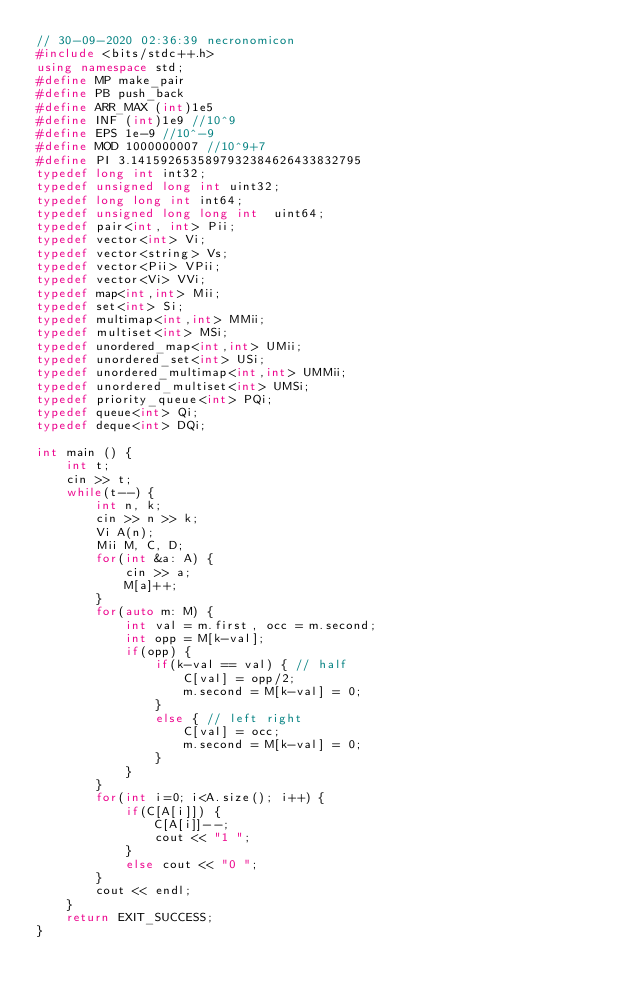<code> <loc_0><loc_0><loc_500><loc_500><_C++_>// 30-09-2020 02:36:39 necronomicon
#include <bits/stdc++.h>
using namespace std;
#define MP make_pair
#define PB push_back
#define ARR_MAX (int)1e5
#define INF (int)1e9 //10^9
#define EPS 1e-9 //10^-9
#define MOD 1000000007 //10^9+7
#define PI 3.1415926535897932384626433832795
typedef long int int32;
typedef unsigned long int uint32;
typedef long long int int64;
typedef unsigned long long int  uint64;
typedef pair<int, int> Pii;
typedef vector<int> Vi;
typedef vector<string> Vs;
typedef vector<Pii> VPii;
typedef vector<Vi> VVi;
typedef map<int,int> Mii;
typedef set<int> Si;
typedef multimap<int,int> MMii;
typedef multiset<int> MSi;
typedef unordered_map<int,int> UMii;
typedef unordered_set<int> USi;
typedef unordered_multimap<int,int> UMMii;
typedef unordered_multiset<int> UMSi;
typedef priority_queue<int> PQi;
typedef queue<int> Qi;
typedef deque<int> DQi;

int main () {
	int t;
    cin >> t;
    while(t--) {
        int n, k;
        cin >> n >> k;
        Vi A(n);
        Mii M, C, D;
        for(int &a: A) {
            cin >> a;
            M[a]++;
        }
        for(auto m: M) {
            int val = m.first, occ = m.second;
            int opp = M[k-val];
            if(opp) {
                if(k-val == val) { // half
                    C[val] = opp/2;
                    m.second = M[k-val] = 0;
                }
                else { // left right
                    C[val] = occ;
                    m.second = M[k-val] = 0;
                }
            }
        }
        for(int i=0; i<A.size(); i++) {
            if(C[A[i]]) {
                C[A[i]]--;
                cout << "1 ";
            }
            else cout << "0 ";
        }
        cout << endl;
    }
    return EXIT_SUCCESS;
}
</code> 